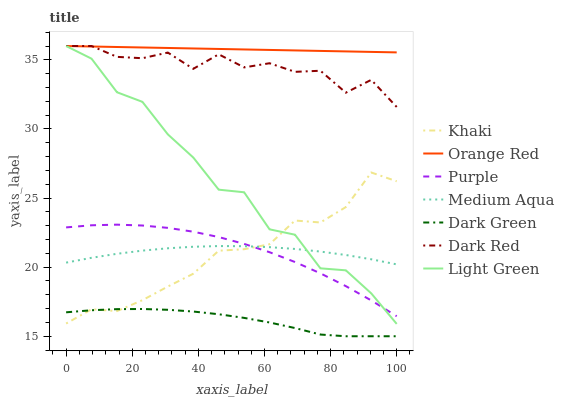Does Dark Green have the minimum area under the curve?
Answer yes or no. Yes. Does Orange Red have the maximum area under the curve?
Answer yes or no. Yes. Does Purple have the minimum area under the curve?
Answer yes or no. No. Does Purple have the maximum area under the curve?
Answer yes or no. No. Is Orange Red the smoothest?
Answer yes or no. Yes. Is Light Green the roughest?
Answer yes or no. Yes. Is Purple the smoothest?
Answer yes or no. No. Is Purple the roughest?
Answer yes or no. No. Does Dark Green have the lowest value?
Answer yes or no. Yes. Does Purple have the lowest value?
Answer yes or no. No. Does Orange Red have the highest value?
Answer yes or no. Yes. Does Purple have the highest value?
Answer yes or no. No. Is Khaki less than Orange Red?
Answer yes or no. Yes. Is Orange Red greater than Dark Green?
Answer yes or no. Yes. Does Orange Red intersect Light Green?
Answer yes or no. Yes. Is Orange Red less than Light Green?
Answer yes or no. No. Is Orange Red greater than Light Green?
Answer yes or no. No. Does Khaki intersect Orange Red?
Answer yes or no. No. 